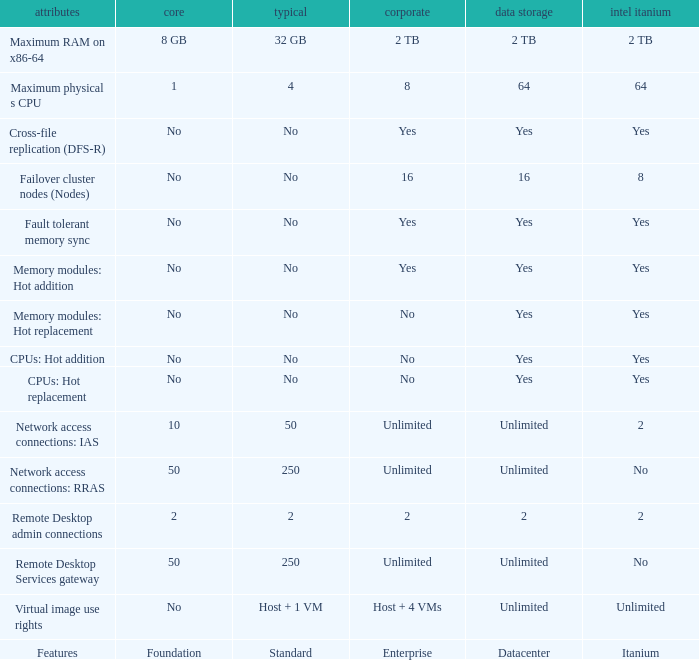Which Features have Yes listed under Datacenter? Cross-file replication (DFS-R), Fault tolerant memory sync, Memory modules: Hot addition, Memory modules: Hot replacement, CPUs: Hot addition, CPUs: Hot replacement. 